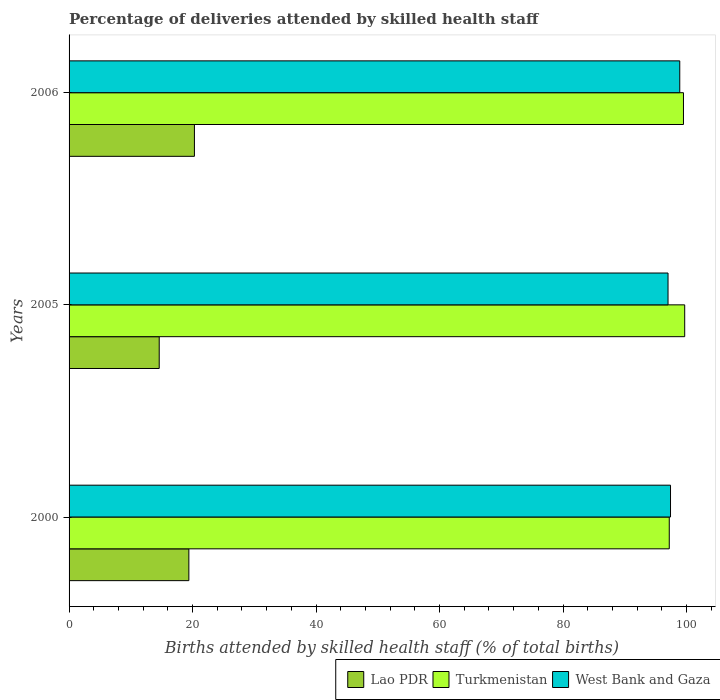How many different coloured bars are there?
Provide a short and direct response. 3. How many bars are there on the 2nd tick from the bottom?
Offer a very short reply. 3. What is the label of the 3rd group of bars from the top?
Make the answer very short. 2000. In how many cases, is the number of bars for a given year not equal to the number of legend labels?
Your response must be concise. 0. What is the percentage of births attended by skilled health staff in West Bank and Gaza in 2006?
Provide a short and direct response. 98.9. Across all years, what is the maximum percentage of births attended by skilled health staff in West Bank and Gaza?
Keep it short and to the point. 98.9. What is the total percentage of births attended by skilled health staff in West Bank and Gaza in the graph?
Your response must be concise. 293.3. What is the difference between the percentage of births attended by skilled health staff in West Bank and Gaza in 2005 and that in 2006?
Your answer should be compact. -1.9. What is the difference between the percentage of births attended by skilled health staff in West Bank and Gaza in 2006 and the percentage of births attended by skilled health staff in Turkmenistan in 2000?
Give a very brief answer. 1.7. What is the average percentage of births attended by skilled health staff in West Bank and Gaza per year?
Provide a short and direct response. 97.77. In the year 2000, what is the difference between the percentage of births attended by skilled health staff in Turkmenistan and percentage of births attended by skilled health staff in West Bank and Gaza?
Keep it short and to the point. -0.2. What is the ratio of the percentage of births attended by skilled health staff in Lao PDR in 2000 to that in 2006?
Provide a short and direct response. 0.96. What is the difference between the highest and the second highest percentage of births attended by skilled health staff in Lao PDR?
Make the answer very short. 0.9. What is the difference between the highest and the lowest percentage of births attended by skilled health staff in Turkmenistan?
Offer a very short reply. 2.5. In how many years, is the percentage of births attended by skilled health staff in Turkmenistan greater than the average percentage of births attended by skilled health staff in Turkmenistan taken over all years?
Provide a short and direct response. 2. Is the sum of the percentage of births attended by skilled health staff in Lao PDR in 2000 and 2005 greater than the maximum percentage of births attended by skilled health staff in West Bank and Gaza across all years?
Ensure brevity in your answer.  No. What does the 2nd bar from the top in 2006 represents?
Your answer should be compact. Turkmenistan. What does the 1st bar from the bottom in 2006 represents?
Your answer should be very brief. Lao PDR. How many bars are there?
Your answer should be compact. 9. What is the difference between two consecutive major ticks on the X-axis?
Ensure brevity in your answer.  20. How many legend labels are there?
Give a very brief answer. 3. How are the legend labels stacked?
Provide a short and direct response. Horizontal. What is the title of the graph?
Offer a very short reply. Percentage of deliveries attended by skilled health staff. What is the label or title of the X-axis?
Your answer should be compact. Births attended by skilled health staff (% of total births). What is the label or title of the Y-axis?
Make the answer very short. Years. What is the Births attended by skilled health staff (% of total births) of Lao PDR in 2000?
Give a very brief answer. 19.4. What is the Births attended by skilled health staff (% of total births) of Turkmenistan in 2000?
Ensure brevity in your answer.  97.2. What is the Births attended by skilled health staff (% of total births) in West Bank and Gaza in 2000?
Make the answer very short. 97.4. What is the Births attended by skilled health staff (% of total births) in Turkmenistan in 2005?
Offer a terse response. 99.7. What is the Births attended by skilled health staff (% of total births) of West Bank and Gaza in 2005?
Your answer should be very brief. 97. What is the Births attended by skilled health staff (% of total births) of Lao PDR in 2006?
Provide a succinct answer. 20.3. What is the Births attended by skilled health staff (% of total births) of Turkmenistan in 2006?
Your answer should be compact. 99.5. What is the Births attended by skilled health staff (% of total births) of West Bank and Gaza in 2006?
Your answer should be compact. 98.9. Across all years, what is the maximum Births attended by skilled health staff (% of total births) in Lao PDR?
Provide a short and direct response. 20.3. Across all years, what is the maximum Births attended by skilled health staff (% of total births) in Turkmenistan?
Give a very brief answer. 99.7. Across all years, what is the maximum Births attended by skilled health staff (% of total births) of West Bank and Gaza?
Your response must be concise. 98.9. Across all years, what is the minimum Births attended by skilled health staff (% of total births) of Lao PDR?
Make the answer very short. 14.6. Across all years, what is the minimum Births attended by skilled health staff (% of total births) in Turkmenistan?
Your response must be concise. 97.2. Across all years, what is the minimum Births attended by skilled health staff (% of total births) of West Bank and Gaza?
Your response must be concise. 97. What is the total Births attended by skilled health staff (% of total births) in Lao PDR in the graph?
Your response must be concise. 54.3. What is the total Births attended by skilled health staff (% of total births) in Turkmenistan in the graph?
Your answer should be very brief. 296.4. What is the total Births attended by skilled health staff (% of total births) of West Bank and Gaza in the graph?
Give a very brief answer. 293.3. What is the difference between the Births attended by skilled health staff (% of total births) in Lao PDR in 2000 and that in 2005?
Make the answer very short. 4.8. What is the difference between the Births attended by skilled health staff (% of total births) in West Bank and Gaza in 2000 and that in 2005?
Your answer should be very brief. 0.4. What is the difference between the Births attended by skilled health staff (% of total births) of Turkmenistan in 2000 and that in 2006?
Offer a terse response. -2.3. What is the difference between the Births attended by skilled health staff (% of total births) in Lao PDR in 2005 and that in 2006?
Your response must be concise. -5.7. What is the difference between the Births attended by skilled health staff (% of total births) in Turkmenistan in 2005 and that in 2006?
Your response must be concise. 0.2. What is the difference between the Births attended by skilled health staff (% of total births) of Lao PDR in 2000 and the Births attended by skilled health staff (% of total births) of Turkmenistan in 2005?
Give a very brief answer. -80.3. What is the difference between the Births attended by skilled health staff (% of total births) in Lao PDR in 2000 and the Births attended by skilled health staff (% of total births) in West Bank and Gaza in 2005?
Provide a short and direct response. -77.6. What is the difference between the Births attended by skilled health staff (% of total births) in Lao PDR in 2000 and the Births attended by skilled health staff (% of total births) in Turkmenistan in 2006?
Provide a succinct answer. -80.1. What is the difference between the Births attended by skilled health staff (% of total births) in Lao PDR in 2000 and the Births attended by skilled health staff (% of total births) in West Bank and Gaza in 2006?
Your answer should be very brief. -79.5. What is the difference between the Births attended by skilled health staff (% of total births) in Turkmenistan in 2000 and the Births attended by skilled health staff (% of total births) in West Bank and Gaza in 2006?
Offer a terse response. -1.7. What is the difference between the Births attended by skilled health staff (% of total births) in Lao PDR in 2005 and the Births attended by skilled health staff (% of total births) in Turkmenistan in 2006?
Provide a succinct answer. -84.9. What is the difference between the Births attended by skilled health staff (% of total births) in Lao PDR in 2005 and the Births attended by skilled health staff (% of total births) in West Bank and Gaza in 2006?
Ensure brevity in your answer.  -84.3. What is the difference between the Births attended by skilled health staff (% of total births) in Turkmenistan in 2005 and the Births attended by skilled health staff (% of total births) in West Bank and Gaza in 2006?
Give a very brief answer. 0.8. What is the average Births attended by skilled health staff (% of total births) in Turkmenistan per year?
Your answer should be very brief. 98.8. What is the average Births attended by skilled health staff (% of total births) in West Bank and Gaza per year?
Offer a very short reply. 97.77. In the year 2000, what is the difference between the Births attended by skilled health staff (% of total births) of Lao PDR and Births attended by skilled health staff (% of total births) of Turkmenistan?
Offer a terse response. -77.8. In the year 2000, what is the difference between the Births attended by skilled health staff (% of total births) in Lao PDR and Births attended by skilled health staff (% of total births) in West Bank and Gaza?
Your answer should be compact. -78. In the year 2005, what is the difference between the Births attended by skilled health staff (% of total births) of Lao PDR and Births attended by skilled health staff (% of total births) of Turkmenistan?
Your answer should be very brief. -85.1. In the year 2005, what is the difference between the Births attended by skilled health staff (% of total births) of Lao PDR and Births attended by skilled health staff (% of total births) of West Bank and Gaza?
Your answer should be very brief. -82.4. In the year 2005, what is the difference between the Births attended by skilled health staff (% of total births) in Turkmenistan and Births attended by skilled health staff (% of total births) in West Bank and Gaza?
Provide a succinct answer. 2.7. In the year 2006, what is the difference between the Births attended by skilled health staff (% of total births) in Lao PDR and Births attended by skilled health staff (% of total births) in Turkmenistan?
Keep it short and to the point. -79.2. In the year 2006, what is the difference between the Births attended by skilled health staff (% of total births) of Lao PDR and Births attended by skilled health staff (% of total births) of West Bank and Gaza?
Offer a terse response. -78.6. What is the ratio of the Births attended by skilled health staff (% of total births) of Lao PDR in 2000 to that in 2005?
Keep it short and to the point. 1.33. What is the ratio of the Births attended by skilled health staff (% of total births) of Turkmenistan in 2000 to that in 2005?
Make the answer very short. 0.97. What is the ratio of the Births attended by skilled health staff (% of total births) of West Bank and Gaza in 2000 to that in 2005?
Keep it short and to the point. 1. What is the ratio of the Births attended by skilled health staff (% of total births) of Lao PDR in 2000 to that in 2006?
Your response must be concise. 0.96. What is the ratio of the Births attended by skilled health staff (% of total births) in Turkmenistan in 2000 to that in 2006?
Your answer should be compact. 0.98. What is the ratio of the Births attended by skilled health staff (% of total births) in Lao PDR in 2005 to that in 2006?
Keep it short and to the point. 0.72. What is the ratio of the Births attended by skilled health staff (% of total births) of Turkmenistan in 2005 to that in 2006?
Keep it short and to the point. 1. What is the ratio of the Births attended by skilled health staff (% of total births) of West Bank and Gaza in 2005 to that in 2006?
Keep it short and to the point. 0.98. What is the difference between the highest and the second highest Births attended by skilled health staff (% of total births) of Turkmenistan?
Your answer should be compact. 0.2. What is the difference between the highest and the second highest Births attended by skilled health staff (% of total births) in West Bank and Gaza?
Offer a very short reply. 1.5. What is the difference between the highest and the lowest Births attended by skilled health staff (% of total births) in Lao PDR?
Ensure brevity in your answer.  5.7. What is the difference between the highest and the lowest Births attended by skilled health staff (% of total births) in Turkmenistan?
Offer a terse response. 2.5. What is the difference between the highest and the lowest Births attended by skilled health staff (% of total births) in West Bank and Gaza?
Keep it short and to the point. 1.9. 